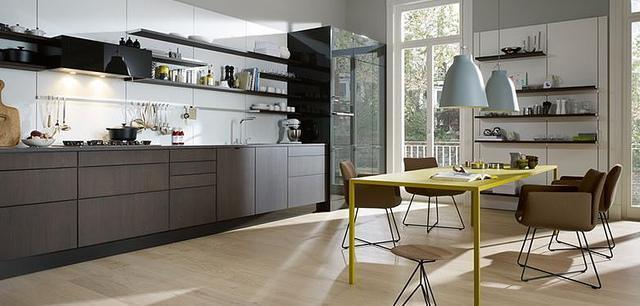How many chairs are in the photo?
Give a very brief answer. 3. How many ovens are in the photo?
Give a very brief answer. 1. 